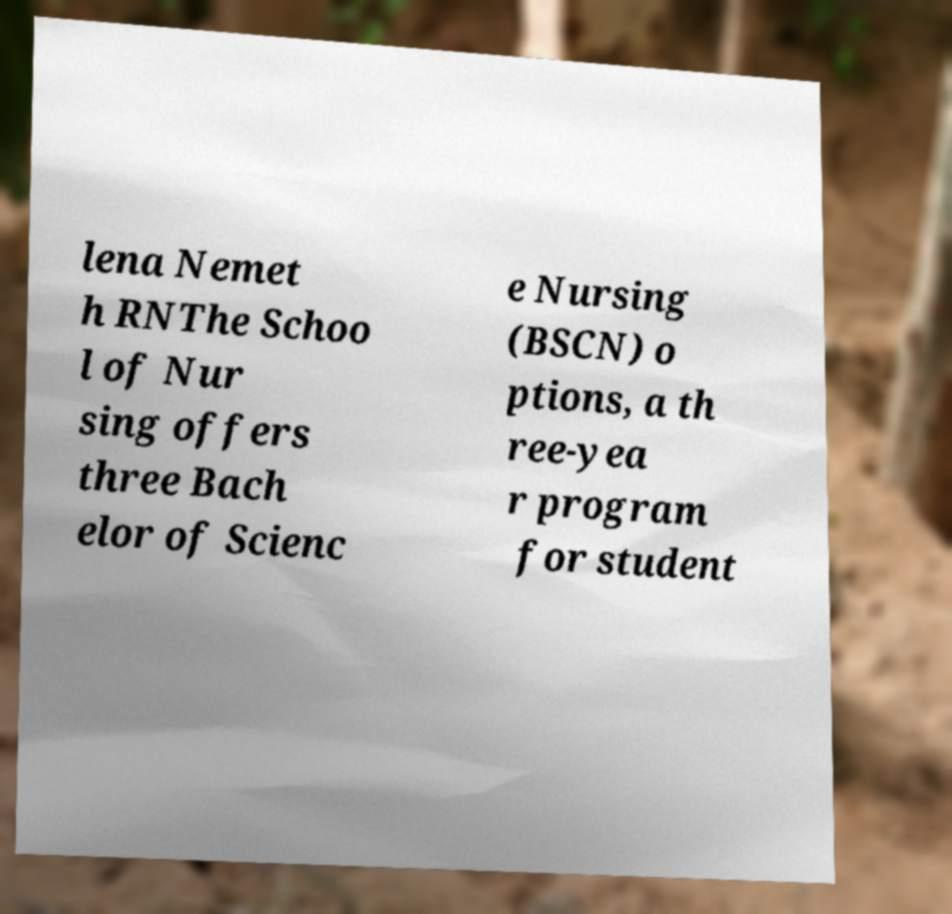What messages or text are displayed in this image? I need them in a readable, typed format. lena Nemet h RNThe Schoo l of Nur sing offers three Bach elor of Scienc e Nursing (BSCN) o ptions, a th ree-yea r program for student 